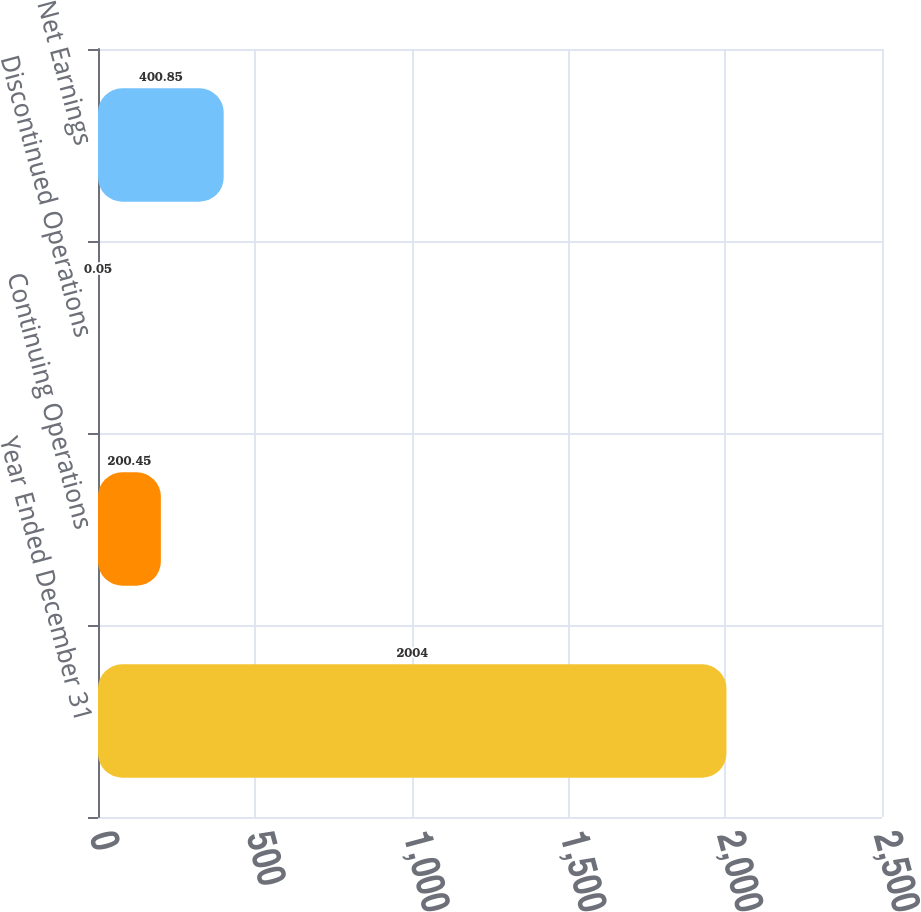Convert chart to OTSL. <chart><loc_0><loc_0><loc_500><loc_500><bar_chart><fcel>Year Ended December 31<fcel>Continuing Operations<fcel>Discontinued Operations<fcel>Net Earnings<nl><fcel>2004<fcel>200.45<fcel>0.05<fcel>400.85<nl></chart> 